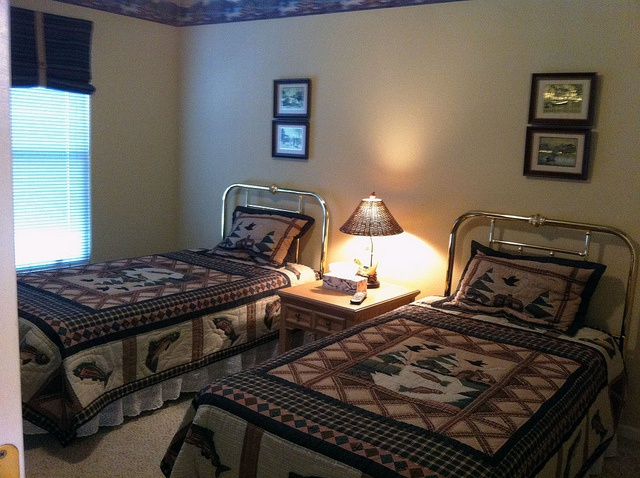Describe the objects in this image and their specific colors. I can see bed in darkgray, black, maroon, and gray tones, bed in darkgray, black, and gray tones, and remote in darkgray, ivory, tan, and black tones in this image. 